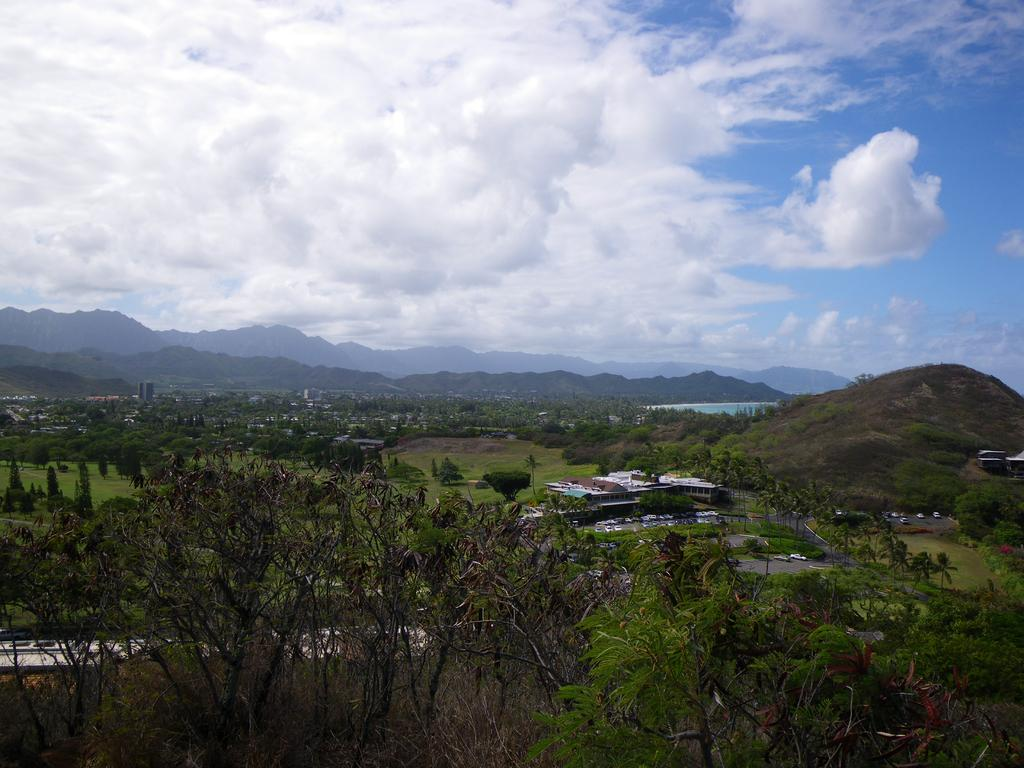What type of vegetation can be seen in the image? There are trees in the image. What is the color of the trees? The trees are green. What structures are visible in the background of the image? There are houses and mountains in the background of the image. What is the color of the sky in the image? The sky is blue and white. What type of rod is being used to measure the group's shame in the image? There is no rod or measurement of shame present in the image. 